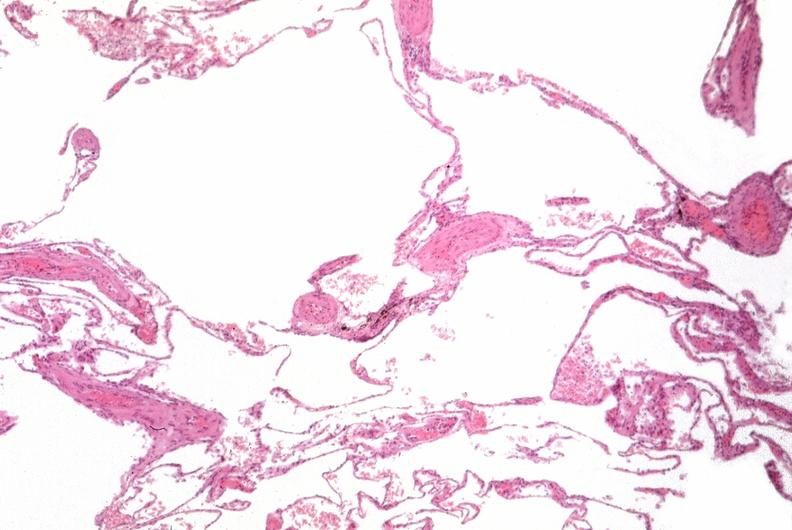s respiratory present?
Answer the question using a single word or phrase. Yes 